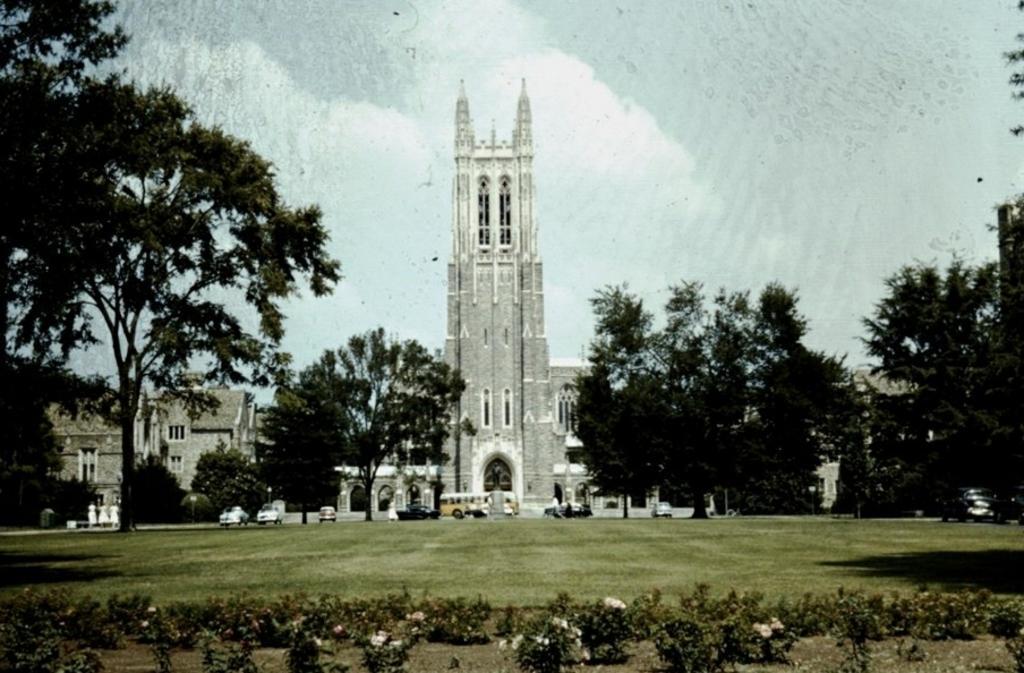Can you describe this image briefly? In this image we can see buildings, motor vehicles, bins, benches, trees and ground. In addition to this we can see sky with clouds, bushes and mud. 